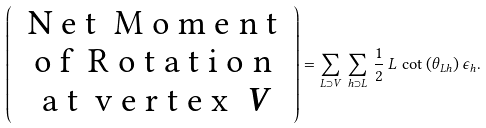<formula> <loc_0><loc_0><loc_500><loc_500>\left ( \begin{array} { c } $ N e t \ M o m e n t $ \\ $ o f \ R o t a t i o n $ \\ $ a t \ v e r t e x $ \ V \end{array} \right ) = \sum _ { L \supset V } \, \sum _ { h \supset L } \, \frac { 1 } { 2 } \, L \, \cot { \left ( \theta _ { L h } \right ) } \, \epsilon _ { h } .</formula> 